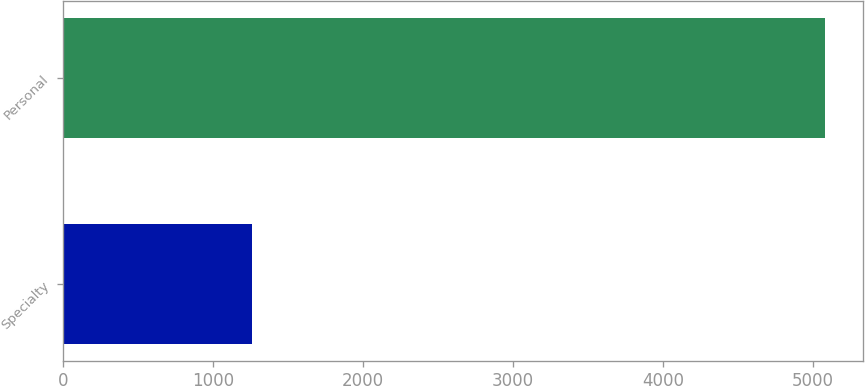<chart> <loc_0><loc_0><loc_500><loc_500><bar_chart><fcel>Specialty<fcel>Personal<nl><fcel>1258<fcel>5081<nl></chart> 